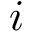Convert formula to latex. <formula><loc_0><loc_0><loc_500><loc_500>i</formula> 